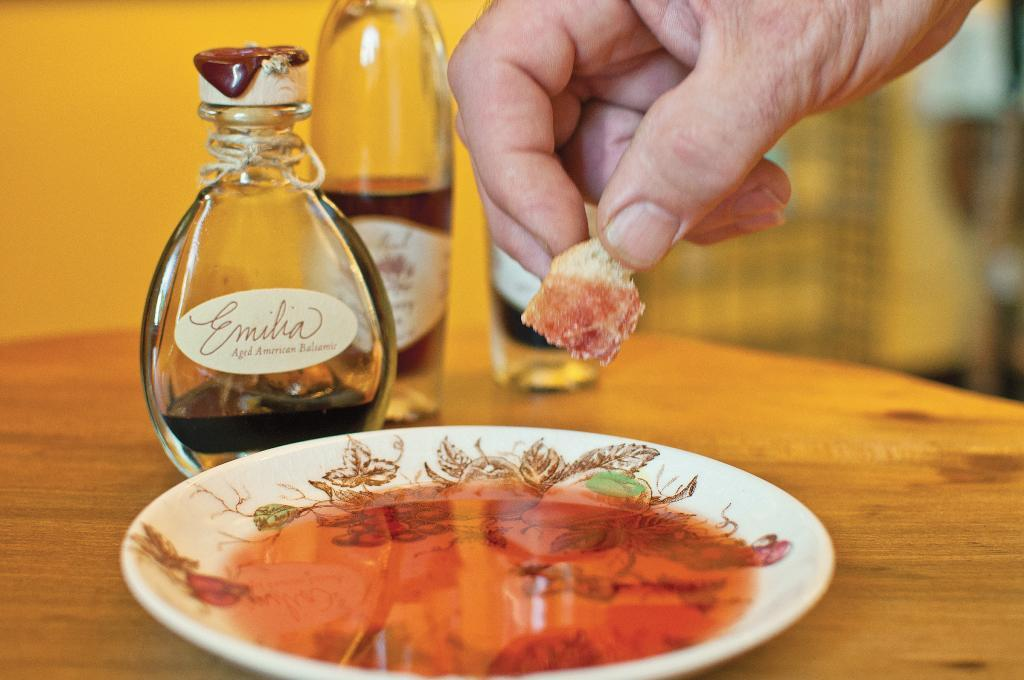<image>
Present a compact description of the photo's key features. A piece of bread is dipped into Emilia brand balsamic oil. 